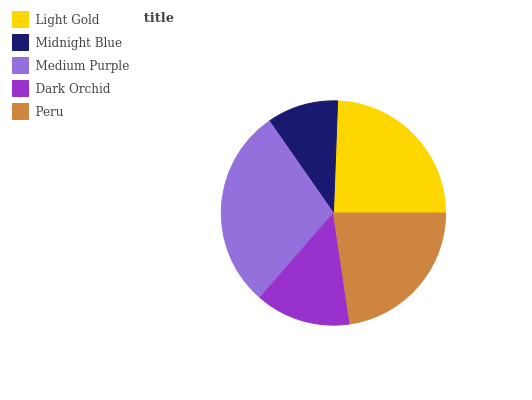Is Midnight Blue the minimum?
Answer yes or no. Yes. Is Medium Purple the maximum?
Answer yes or no. Yes. Is Medium Purple the minimum?
Answer yes or no. No. Is Midnight Blue the maximum?
Answer yes or no. No. Is Medium Purple greater than Midnight Blue?
Answer yes or no. Yes. Is Midnight Blue less than Medium Purple?
Answer yes or no. Yes. Is Midnight Blue greater than Medium Purple?
Answer yes or no. No. Is Medium Purple less than Midnight Blue?
Answer yes or no. No. Is Peru the high median?
Answer yes or no. Yes. Is Peru the low median?
Answer yes or no. Yes. Is Medium Purple the high median?
Answer yes or no. No. Is Midnight Blue the low median?
Answer yes or no. No. 